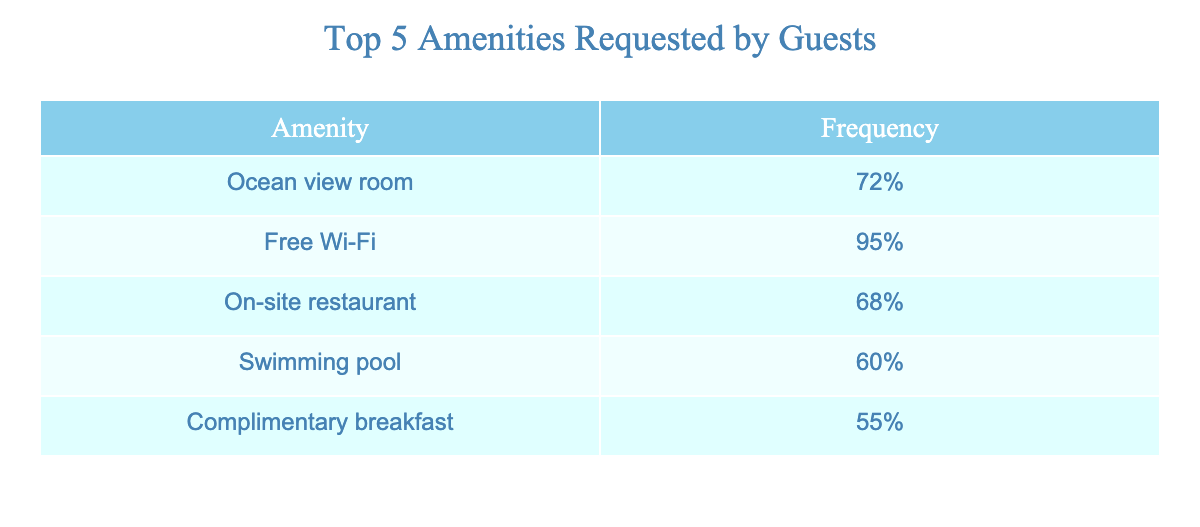What is the frequency percentage of guests requesting a swimming pool? The table shows the frequency of each amenity requested by guests. For a swimming pool, the frequency is 60%.
Answer: 60% Which amenity has the highest frequency of requests? By examining the frequency column, Free Wi-Fi has the highest percentage at 95%.
Answer: Free Wi-Fi Is complementary breakfast requested more than ocean view rooms? The frequency for complimentary breakfast is 55%, while for ocean view rooms, it is 72%. Since 55% is less than 72%, the statement is false.
Answer: No What is the average frequency of the top five amenities? To calculate the average, sum the frequencies: 72% + 95% + 68% + 60% + 55% = 350%. There are 5 amenities, so the average is 350% divided by 5 which equals 70%.
Answer: 70% Do at least two amenities have a frequency of over 70%? The frequencies are 72%, 95%, 68%, 60%, and 55%. Only Free Wi-Fi (95%) and ocean view room (72%) exceed 70%, confirming that at least two amenities meet the criteria.
Answer: Yes What is the difference in frequency between the on-site restaurant and complimentary breakfast? The frequency for on-site restaurant is 68% and for complimentary breakfast is 55%. The difference is 68% - 55% = 13%.
Answer: 13% Which amenities have a frequency below 60%? The table indicates that only the complementary breakfast (55%) and swimming pool (60%) are below 60%. Swimming pool is exactly at 60% but does not follow the condition of being below.
Answer: Complimentary breakfast If the frequency percentage of each amenity were to rank, what would be the position of the swimming pool? The frequencies from highest to lowest are: Free Wi-Fi (1), Ocean view room (2), On-site restaurant (3), Swimming pool (4), and Complimentary breakfast (5). Swimming pool would hold the 4th position.
Answer: 4th position How many amenities have a frequency percentage between 60% and 70%? From the table, Swimming pool (60%) and on-site restaurant (68%) fall within the specified range. Therefore, there are two amenities that meet the criteria.
Answer: 2 